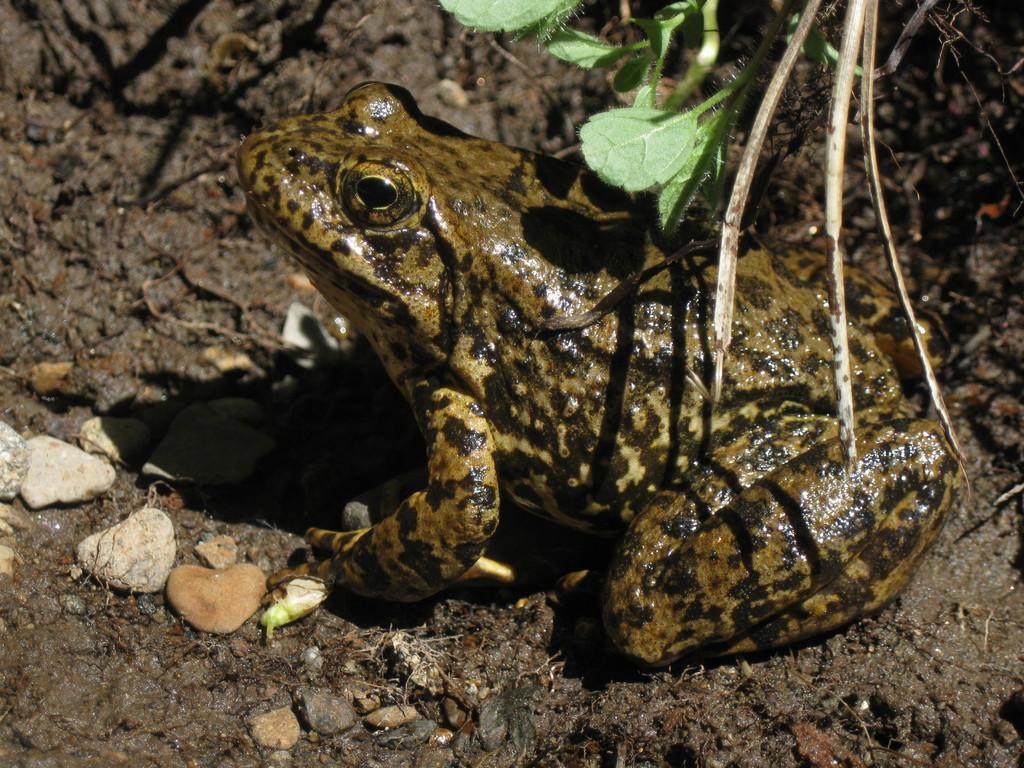Describe this image in one or two sentences. In this picture, I can see a frog a ground, few stones and leaves. 